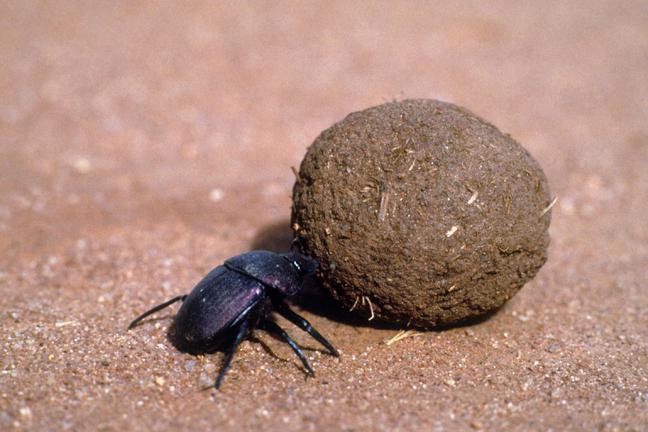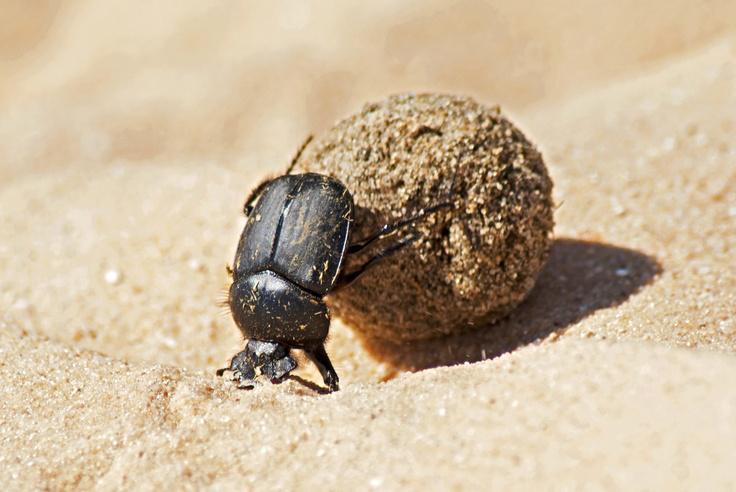The first image is the image on the left, the second image is the image on the right. Evaluate the accuracy of this statement regarding the images: "Each image contains exactly one brown ball and one beetle, and the beetle in the righthand image has its front legs on the ground.". Is it true? Answer yes or no. Yes. The first image is the image on the left, the second image is the image on the right. Examine the images to the left and right. Is the description "At least one of the beetles does not have any of its feet touching the ground." accurate? Answer yes or no. No. 